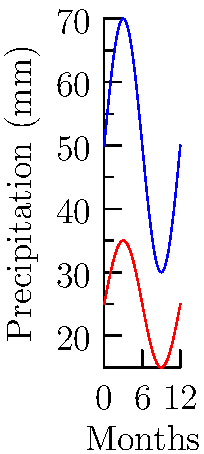The graph shows annual precipitation patterns for two regions. If Region B's precipitation data were scaled up by a factor of 2, how would its maximum precipitation compare to Region A's maximum precipitation? To solve this problem, we need to follow these steps:

1. Identify the maximum precipitation for each region:
   - Region A (blue): Maximum is approximately 70 mm
   - Region B (red): Maximum is approximately 35 mm

2. Scale Region B's precipitation by a factor of 2:
   - Scaled maximum for Region B = $35 \text{ mm} \times 2 = 70 \text{ mm}$

3. Compare the scaled maximum of Region B to Region A's maximum:
   - Region A maximum: 70 mm
   - Scaled Region B maximum: 70 mm

4. Conclusion:
   After scaling Region B's precipitation by a factor of 2, its maximum precipitation would be equal to Region A's maximum precipitation.

This transformation represents a vertical stretch of Region B's graph by a scale factor of 2, which would align its peak with Region A's peak.
Answer: Equal 